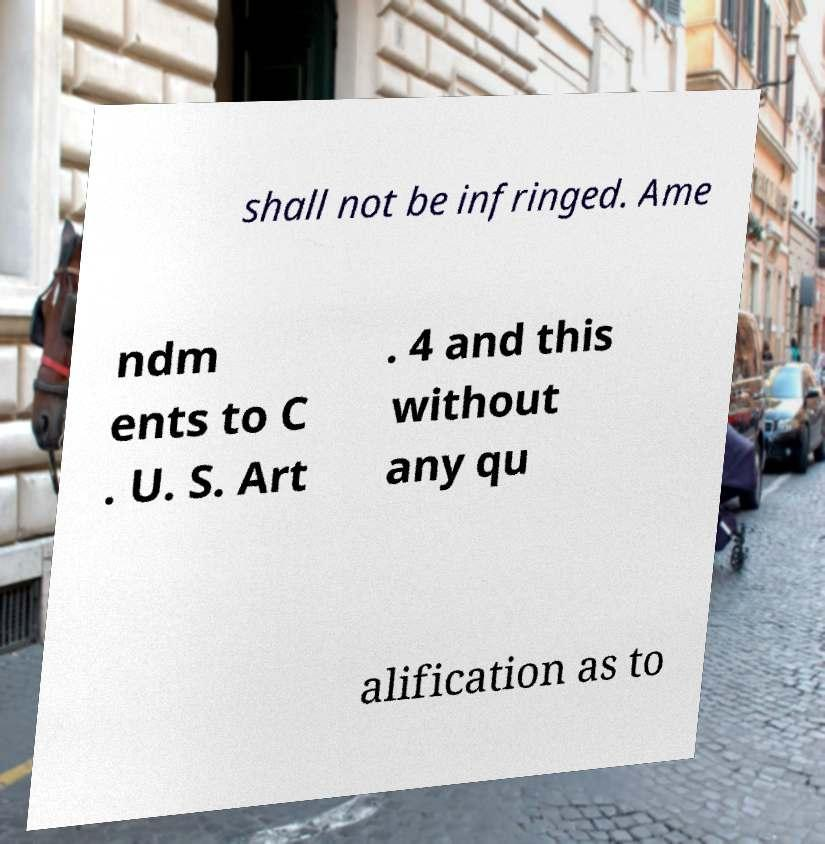I need the written content from this picture converted into text. Can you do that? shall not be infringed. Ame ndm ents to C . U. S. Art . 4 and this without any qu alification as to 